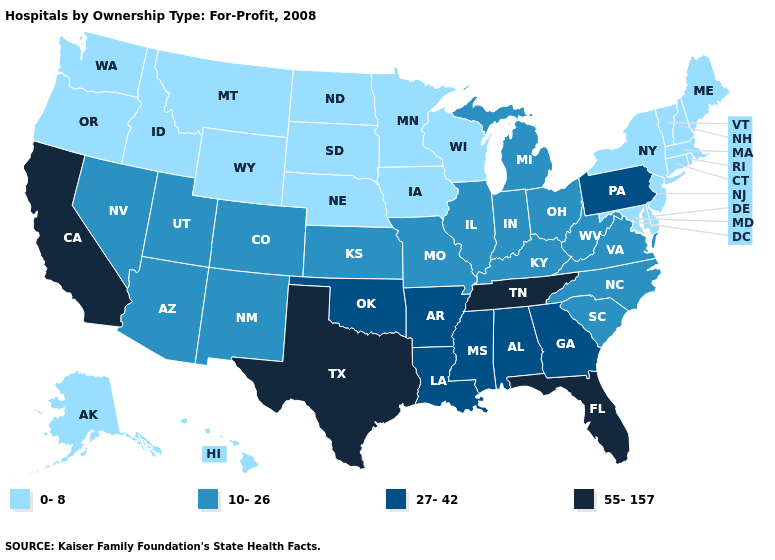What is the value of Delaware?
Short answer required. 0-8. What is the highest value in states that border California?
Be succinct. 10-26. Which states hav the highest value in the South?
Quick response, please. Florida, Tennessee, Texas. Does Massachusetts have the lowest value in the Northeast?
Short answer required. Yes. What is the value of Iowa?
Answer briefly. 0-8. What is the value of Tennessee?
Quick response, please. 55-157. Name the states that have a value in the range 27-42?
Keep it brief. Alabama, Arkansas, Georgia, Louisiana, Mississippi, Oklahoma, Pennsylvania. What is the value of New Hampshire?
Keep it brief. 0-8. Does the map have missing data?
Be succinct. No. What is the value of South Carolina?
Quick response, please. 10-26. What is the value of Virginia?
Write a very short answer. 10-26. What is the value of Louisiana?
Keep it brief. 27-42. What is the lowest value in the West?
Concise answer only. 0-8. What is the highest value in the USA?
Answer briefly. 55-157. How many symbols are there in the legend?
Answer briefly. 4. 